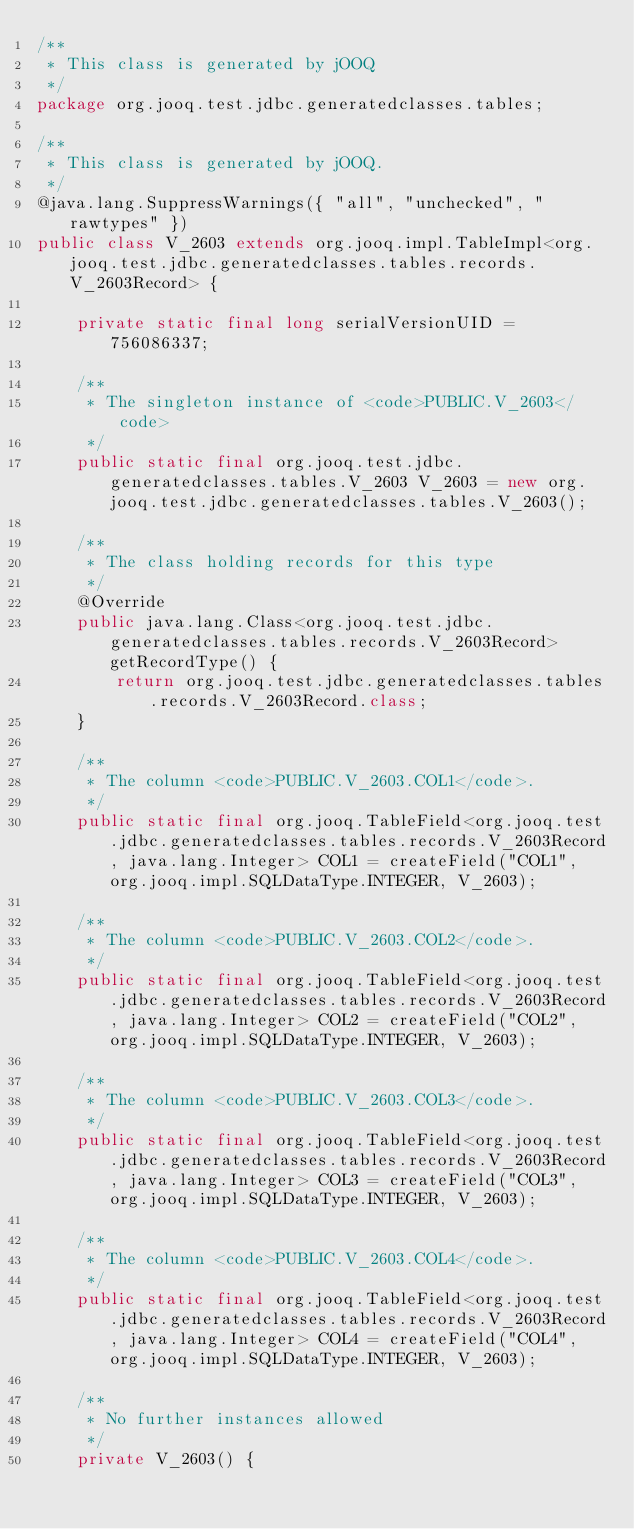Convert code to text. <code><loc_0><loc_0><loc_500><loc_500><_Java_>/**
 * This class is generated by jOOQ
 */
package org.jooq.test.jdbc.generatedclasses.tables;

/**
 * This class is generated by jOOQ.
 */
@java.lang.SuppressWarnings({ "all", "unchecked", "rawtypes" })
public class V_2603 extends org.jooq.impl.TableImpl<org.jooq.test.jdbc.generatedclasses.tables.records.V_2603Record> {

	private static final long serialVersionUID = 756086337;

	/**
	 * The singleton instance of <code>PUBLIC.V_2603</code>
	 */
	public static final org.jooq.test.jdbc.generatedclasses.tables.V_2603 V_2603 = new org.jooq.test.jdbc.generatedclasses.tables.V_2603();

	/**
	 * The class holding records for this type
	 */
	@Override
	public java.lang.Class<org.jooq.test.jdbc.generatedclasses.tables.records.V_2603Record> getRecordType() {
		return org.jooq.test.jdbc.generatedclasses.tables.records.V_2603Record.class;
	}

	/**
	 * The column <code>PUBLIC.V_2603.COL1</code>. 
	 */
	public static final org.jooq.TableField<org.jooq.test.jdbc.generatedclasses.tables.records.V_2603Record, java.lang.Integer> COL1 = createField("COL1", org.jooq.impl.SQLDataType.INTEGER, V_2603);

	/**
	 * The column <code>PUBLIC.V_2603.COL2</code>. 
	 */
	public static final org.jooq.TableField<org.jooq.test.jdbc.generatedclasses.tables.records.V_2603Record, java.lang.Integer> COL2 = createField("COL2", org.jooq.impl.SQLDataType.INTEGER, V_2603);

	/**
	 * The column <code>PUBLIC.V_2603.COL3</code>. 
	 */
	public static final org.jooq.TableField<org.jooq.test.jdbc.generatedclasses.tables.records.V_2603Record, java.lang.Integer> COL3 = createField("COL3", org.jooq.impl.SQLDataType.INTEGER, V_2603);

	/**
	 * The column <code>PUBLIC.V_2603.COL4</code>. 
	 */
	public static final org.jooq.TableField<org.jooq.test.jdbc.generatedclasses.tables.records.V_2603Record, java.lang.Integer> COL4 = createField("COL4", org.jooq.impl.SQLDataType.INTEGER, V_2603);

	/**
	 * No further instances allowed
	 */
	private V_2603() {</code> 